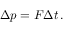<formula> <loc_0><loc_0><loc_500><loc_500>\Delta p = F \Delta t \, .</formula> 